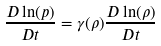Convert formula to latex. <formula><loc_0><loc_0><loc_500><loc_500>\frac { D \ln ( p ) } { D t } = \gamma ( \rho ) \frac { D \ln ( \rho ) } { D t }</formula> 